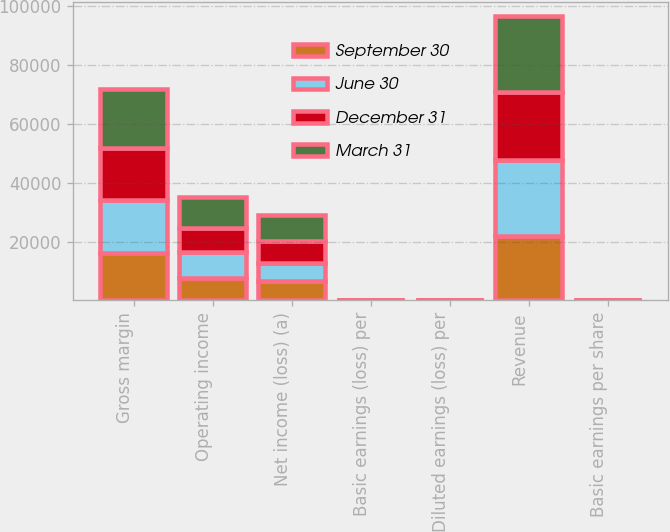<chart> <loc_0><loc_0><loc_500><loc_500><stacked_bar_chart><ecel><fcel>Gross margin<fcel>Operating income<fcel>Net income (loss) (a)<fcel>Basic earnings (loss) per<fcel>Diluted earnings (loss) per<fcel>Revenue<fcel>Basic earnings per share<nl><fcel>September 30<fcel>16260<fcel>7708<fcel>6576<fcel>0.85<fcel>0.84<fcel>21928<fcel>0.73<nl><fcel>June 30<fcel>17854<fcel>8679<fcel>6302<fcel>0.82<fcel>0.82<fcel>25826<fcel>0.81<nl><fcel>December 31<fcel>17550<fcel>8292<fcel>7424<fcel>0.96<fcel>0.95<fcel>23212<fcel>0.71<nl><fcel>March 31<fcel>20343<fcel>10379<fcel>8873<fcel>1.15<fcel>1.14<fcel>25605<fcel>1.05<nl></chart> 